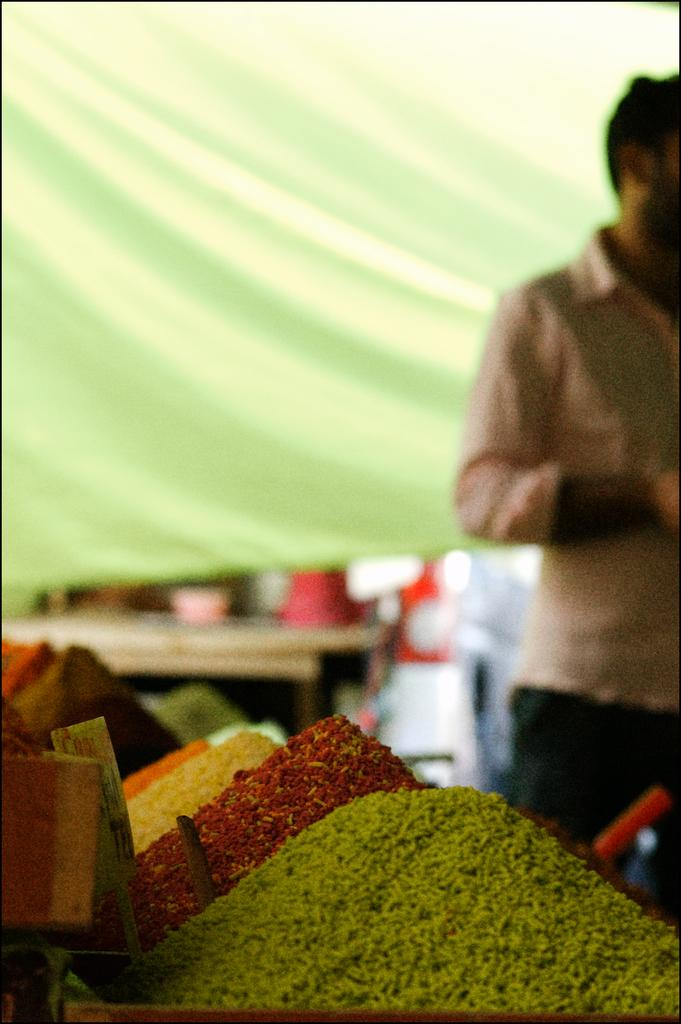What colors are present in the image? There are objects in green, red, yellow, and orange colors in the image. Can you describe the objects in each color? Unfortunately, the facts provided do not specify the objects in each color. Where is the person located in the image? The person is standing in the right corner of the image. What type of throat-soothing action can be seen being performed on the apple in the image? There is no apple or throat-soothing action present in the image. 